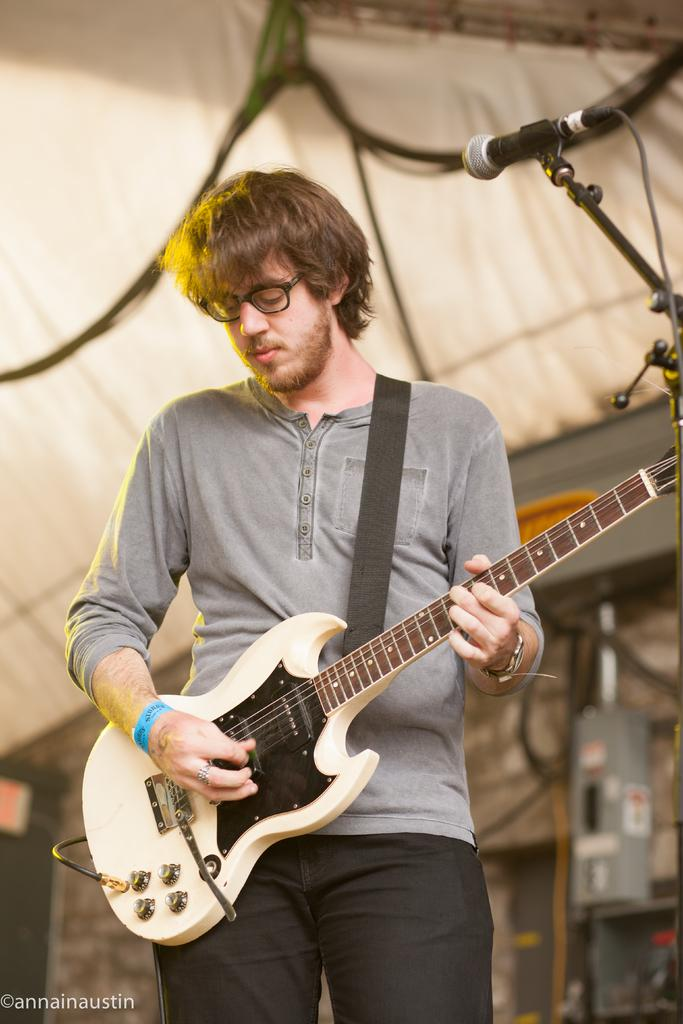What is the man in the image holding? The man is holding a guitar. What object is present in the image that is typically used for amplifying sound? There is a microphone in the image. What activity might the man be engaged in, based on the objects present in the image? The man might be engaged in playing music or performing, given that he is holding a guitar and there is a microphone present. What type of creature is playing volleyball in the image? There is no creature or volleyball present in the image. 